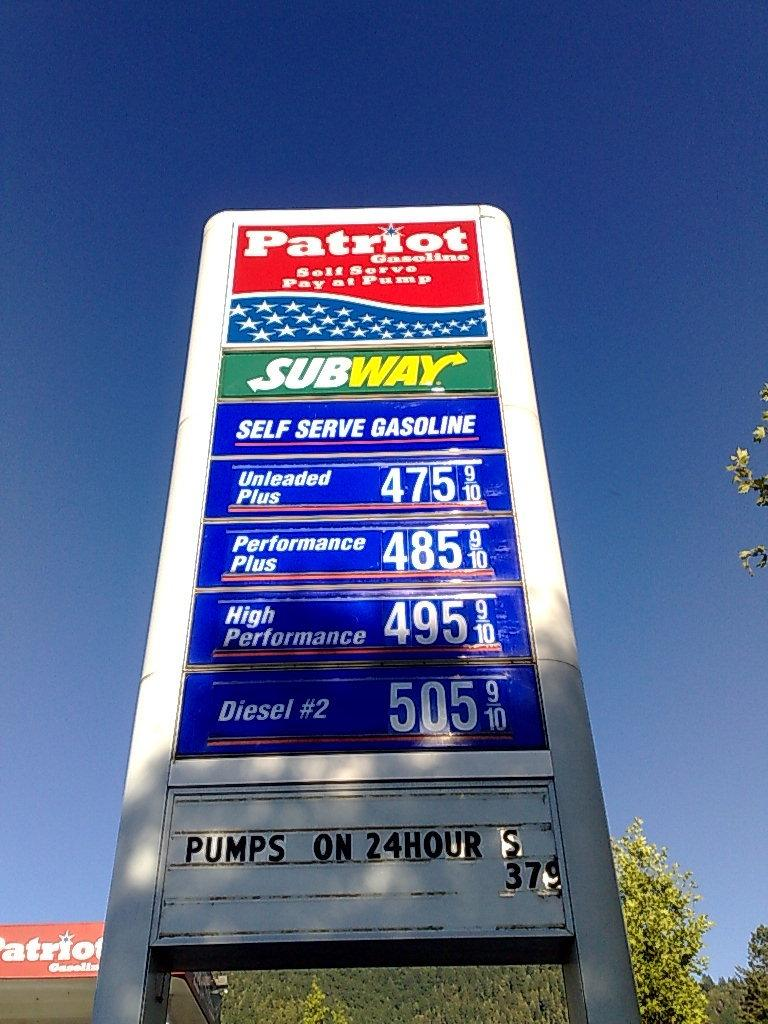<image>
Render a clear and concise summary of the photo. Gas sign with subway and patriot sign wrote on it 